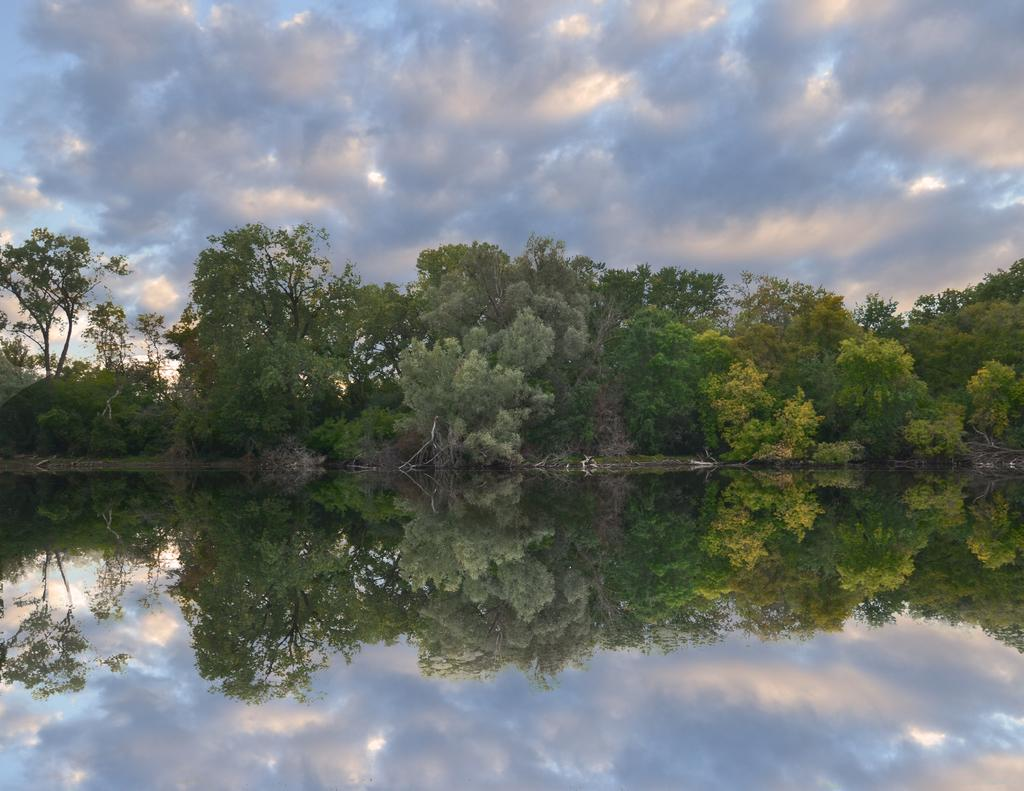What is the main feature of the image? There is a big lake in the image. What can be seen around the lake? There are many trees near the lake. What is visible in the sky? Clouds are visible in the sky. What can be observed in the water? There is a reflection of trees and clouds in the water. What is the tendency of the icicle in the image? There is no icicle present in the image. 